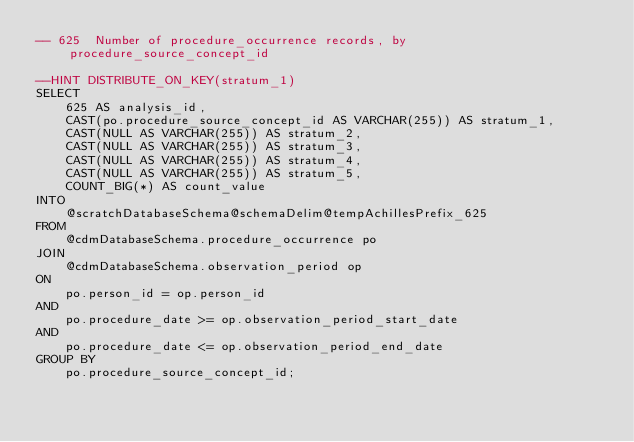Convert code to text. <code><loc_0><loc_0><loc_500><loc_500><_SQL_>-- 625	Number of procedure_occurrence records, by procedure_source_concept_id

--HINT DISTRIBUTE_ON_KEY(stratum_1)
SELECT 
	625 AS analysis_id,
	CAST(po.procedure_source_concept_id AS VARCHAR(255)) AS stratum_1,
	CAST(NULL AS VARCHAR(255)) AS stratum_2,
	CAST(NULL AS VARCHAR(255)) AS stratum_3,
	CAST(NULL AS VARCHAR(255)) AS stratum_4,
	CAST(NULL AS VARCHAR(255)) AS stratum_5,
	COUNT_BIG(*) AS count_value
INTO 
	@scratchDatabaseSchema@schemaDelim@tempAchillesPrefix_625
FROM 
	@cdmDatabaseSchema.procedure_occurrence po
JOIN 
	@cdmDatabaseSchema.observation_period op 
ON 
	po.person_id = op.person_id
AND 
	po.procedure_date >= op.observation_period_start_date
AND 
	po.procedure_date <= op.observation_period_end_date
GROUP BY 
	po.procedure_source_concept_id;
</code> 